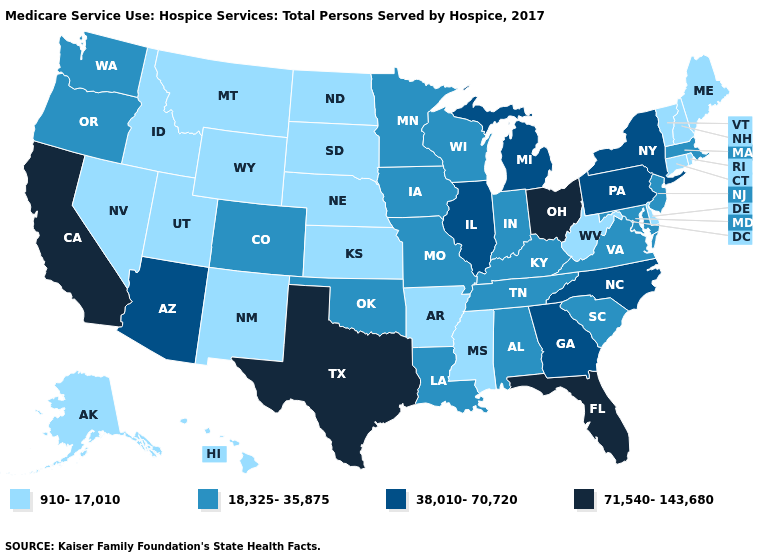What is the value of Tennessee?
Be succinct. 18,325-35,875. Name the states that have a value in the range 38,010-70,720?
Concise answer only. Arizona, Georgia, Illinois, Michigan, New York, North Carolina, Pennsylvania. Name the states that have a value in the range 71,540-143,680?
Answer briefly. California, Florida, Ohio, Texas. What is the value of Minnesota?
Keep it brief. 18,325-35,875. Name the states that have a value in the range 38,010-70,720?
Concise answer only. Arizona, Georgia, Illinois, Michigan, New York, North Carolina, Pennsylvania. What is the highest value in states that border Pennsylvania?
Answer briefly. 71,540-143,680. Among the states that border Minnesota , which have the lowest value?
Short answer required. North Dakota, South Dakota. What is the highest value in the Northeast ?
Write a very short answer. 38,010-70,720. What is the value of North Carolina?
Keep it brief. 38,010-70,720. Which states have the lowest value in the USA?
Keep it brief. Alaska, Arkansas, Connecticut, Delaware, Hawaii, Idaho, Kansas, Maine, Mississippi, Montana, Nebraska, Nevada, New Hampshire, New Mexico, North Dakota, Rhode Island, South Dakota, Utah, Vermont, West Virginia, Wyoming. What is the highest value in states that border Arizona?
Be succinct. 71,540-143,680. What is the value of Texas?
Give a very brief answer. 71,540-143,680. What is the value of Nebraska?
Answer briefly. 910-17,010. How many symbols are there in the legend?
Concise answer only. 4. What is the value of New Mexico?
Write a very short answer. 910-17,010. 